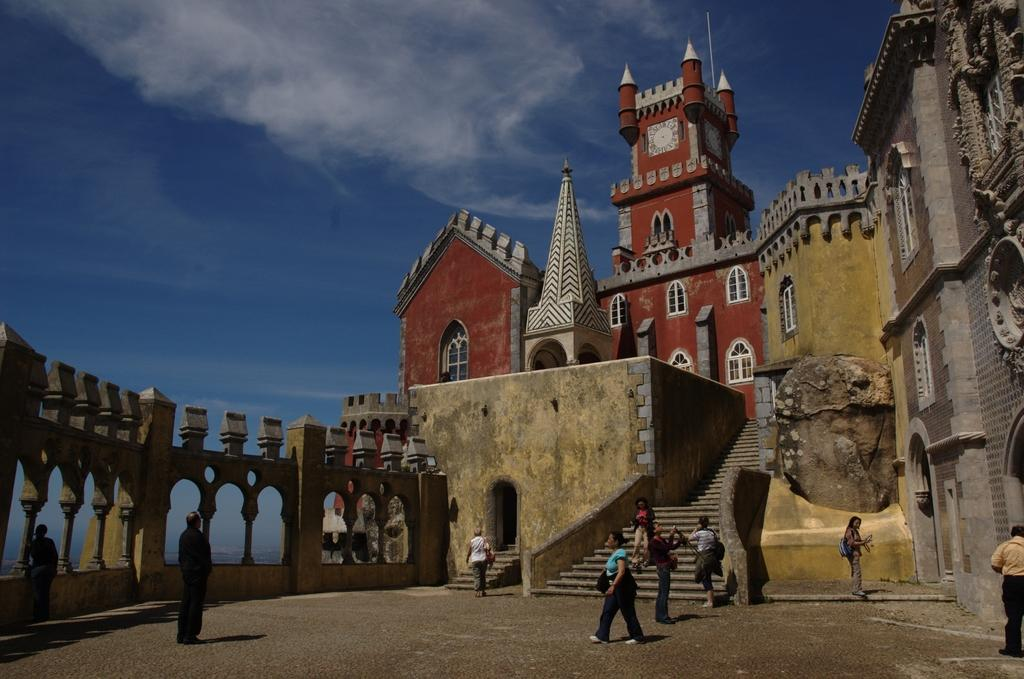What is the main subject of the image? There is a monument in the image. Are there any people present in the image? Yes, there are people in front of the monument. What can be seen on the left side of the image? There are pillars on the left side of the image. How many books can be seen on the monument in the image? There are no books present on the monument in the image. What type of manager is standing next to the monument in the image? There is no manager present in the image; only people are visible in front of the monument. 